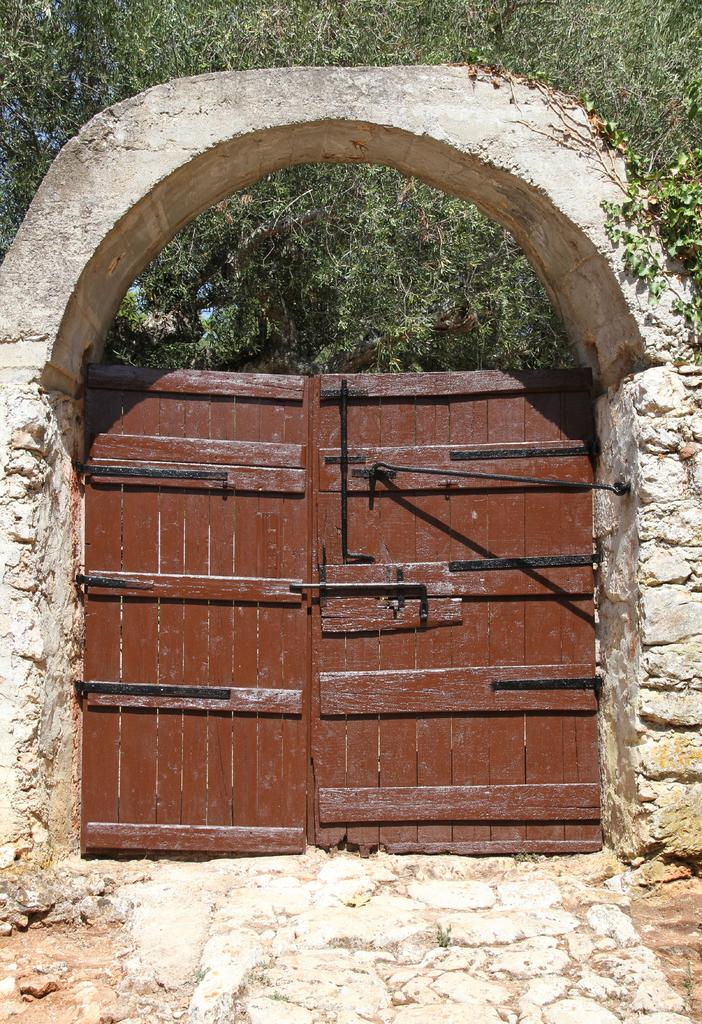What type of structure can be seen in the image? There is a door in the image. What is the color of the door? The door is brown in color. What else can be seen in the image besides the door? There is a wall in the image. What is the color of the wall? The wall is white in color. What can be seen in the background of the image? There are trees in the background of the image. Is there a wire connected to the door in the image? There is no wire connected to the door in the image. Can you see any steam coming from the wall in the image? There is no steam visible in the image. 